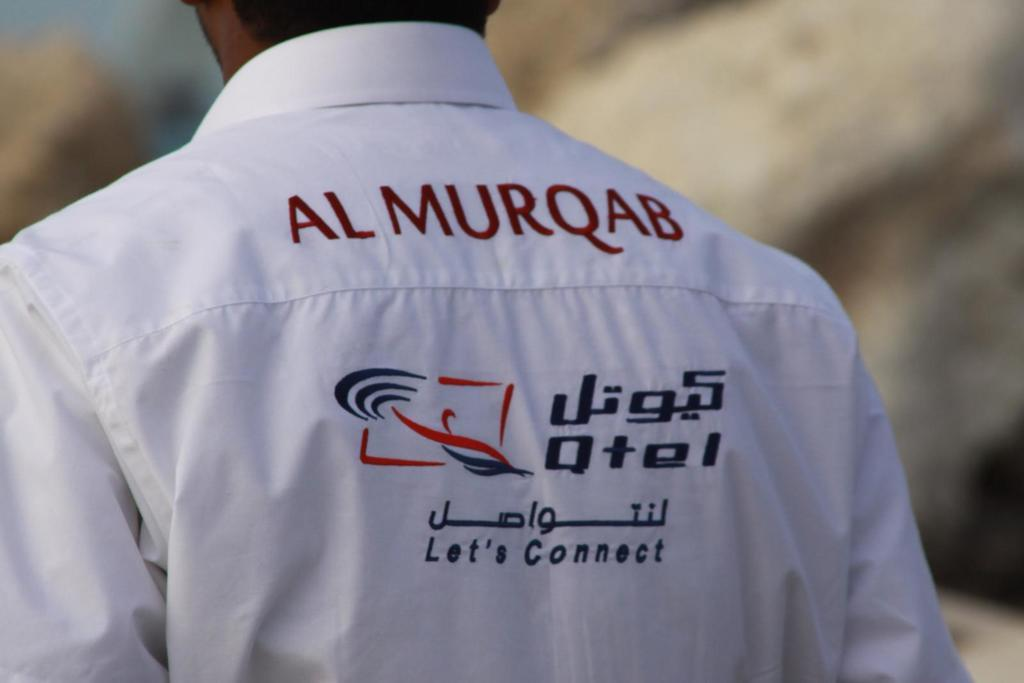<image>
Give a short and clear explanation of the subsequent image. Almurqab written on the back of a shirt worn by a man with a logo below that states lets connect. 